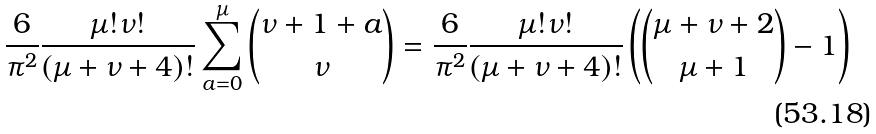<formula> <loc_0><loc_0><loc_500><loc_500>\frac { 6 } { \pi ^ { 2 } } \frac { \mu ! \nu ! } { ( \mu + \nu + 4 ) ! } \sum _ { a = 0 } ^ { \mu } \binom { \nu + 1 + a } { \nu } = \frac { 6 } { \pi ^ { 2 } } \frac { \mu ! \nu ! } { ( \mu + \nu + 4 ) ! } \left ( \binom { \mu + \nu + 2 } { \mu + 1 } - 1 \right )</formula> 